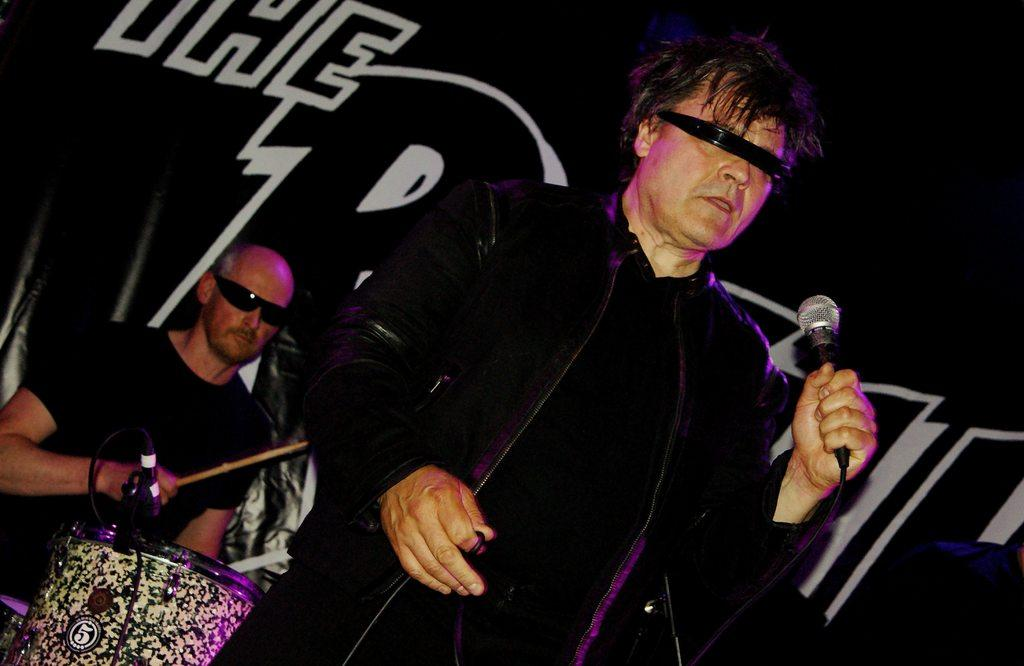What is the man in the image doing? The man is standing and holding a microphone. What is the person sitting doing in the image? The person sitting is playing the drums. Can you describe the interaction between the man and the person sitting? The man is holding a microphone, which suggests he might be singing or speaking, while the person sitting is playing the drums, indicating they might be performing together. What type of plants can be seen growing on the nation in the image? There is no reference to a nation or plants in the image, so it is not possible to answer that question. 